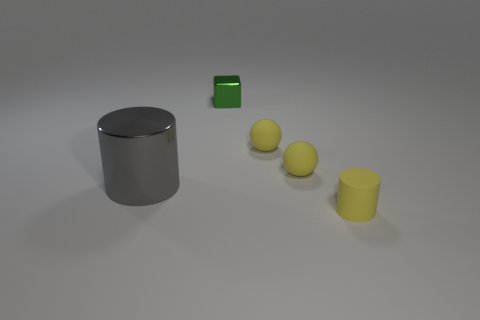What number of metal objects are either big gray things or green cubes?
Make the answer very short. 2. Are there more blue metallic things than small things?
Give a very brief answer. No. The yellow object in front of the thing that is on the left side of the small cube is what shape?
Provide a short and direct response. Cylinder. There is a cylinder to the left of the yellow matte cylinder that is to the right of the green cube; are there any spheres left of it?
Your response must be concise. No. What is the color of the metal thing that is the same size as the yellow matte cylinder?
Your response must be concise. Green. What is the size of the cylinder right of the green shiny block that is on the right side of the big gray metal cylinder?
Ensure brevity in your answer.  Small. What number of other cylinders have the same color as the large shiny cylinder?
Provide a succinct answer. 0. How many other things are the same size as the matte cylinder?
Give a very brief answer. 3. What number of other tiny rubber objects are the same shape as the tiny green object?
Your answer should be very brief. 0. What is the material of the cube?
Offer a very short reply. Metal. 